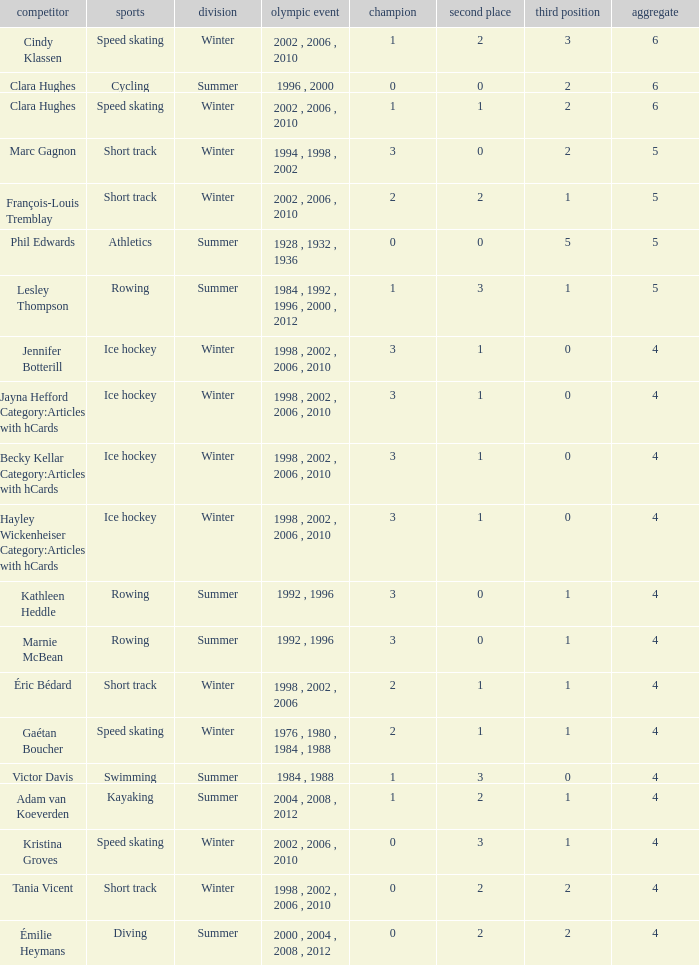What is the lowest number of bronze a short track athlete with 0 gold medals has? 2.0. 